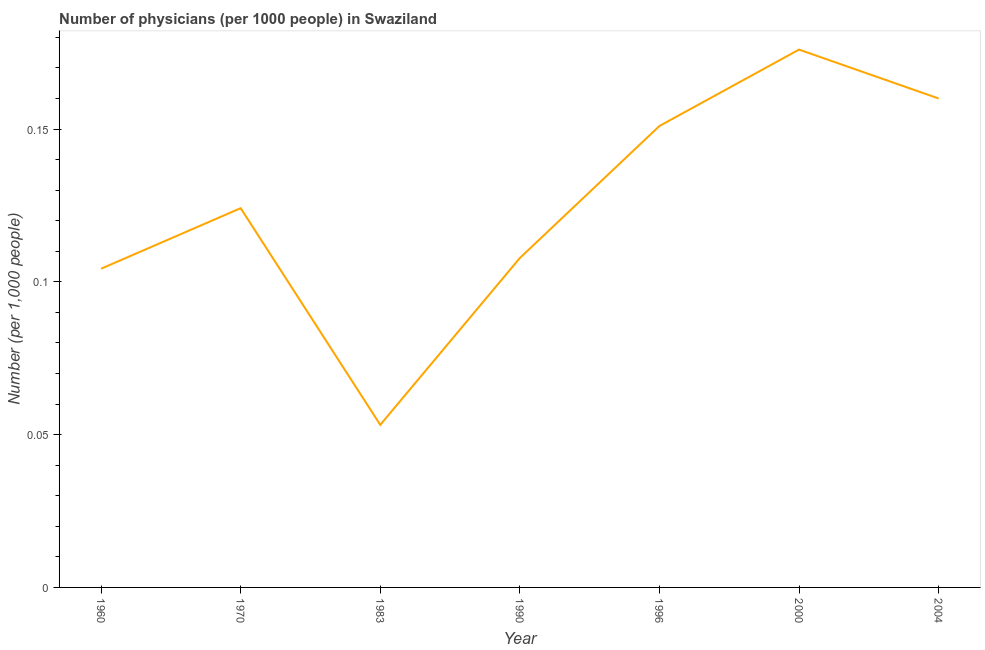What is the number of physicians in 2004?
Keep it short and to the point. 0.16. Across all years, what is the maximum number of physicians?
Offer a very short reply. 0.18. Across all years, what is the minimum number of physicians?
Offer a very short reply. 0.05. In which year was the number of physicians minimum?
Give a very brief answer. 1983. What is the sum of the number of physicians?
Provide a succinct answer. 0.88. What is the difference between the number of physicians in 1996 and 2004?
Provide a short and direct response. -0.01. What is the average number of physicians per year?
Your response must be concise. 0.13. What is the median number of physicians?
Provide a succinct answer. 0.12. What is the ratio of the number of physicians in 1983 to that in 2004?
Give a very brief answer. 0.33. Is the number of physicians in 1970 less than that in 2000?
Offer a terse response. Yes. What is the difference between the highest and the second highest number of physicians?
Provide a short and direct response. 0.02. Is the sum of the number of physicians in 1970 and 2004 greater than the maximum number of physicians across all years?
Provide a succinct answer. Yes. What is the difference between the highest and the lowest number of physicians?
Offer a terse response. 0.12. How many lines are there?
Offer a terse response. 1. How many years are there in the graph?
Offer a terse response. 7. What is the title of the graph?
Your answer should be compact. Number of physicians (per 1000 people) in Swaziland. What is the label or title of the X-axis?
Provide a short and direct response. Year. What is the label or title of the Y-axis?
Give a very brief answer. Number (per 1,0 people). What is the Number (per 1,000 people) in 1960?
Provide a short and direct response. 0.1. What is the Number (per 1,000 people) in 1970?
Offer a terse response. 0.12. What is the Number (per 1,000 people) of 1983?
Your answer should be compact. 0.05. What is the Number (per 1,000 people) in 1990?
Provide a short and direct response. 0.11. What is the Number (per 1,000 people) in 1996?
Your answer should be compact. 0.15. What is the Number (per 1,000 people) of 2000?
Make the answer very short. 0.18. What is the Number (per 1,000 people) of 2004?
Provide a short and direct response. 0.16. What is the difference between the Number (per 1,000 people) in 1960 and 1970?
Your response must be concise. -0.02. What is the difference between the Number (per 1,000 people) in 1960 and 1983?
Your response must be concise. 0.05. What is the difference between the Number (per 1,000 people) in 1960 and 1990?
Offer a terse response. -0. What is the difference between the Number (per 1,000 people) in 1960 and 1996?
Your answer should be very brief. -0.05. What is the difference between the Number (per 1,000 people) in 1960 and 2000?
Your answer should be compact. -0.07. What is the difference between the Number (per 1,000 people) in 1960 and 2004?
Your answer should be very brief. -0.06. What is the difference between the Number (per 1,000 people) in 1970 and 1983?
Keep it short and to the point. 0.07. What is the difference between the Number (per 1,000 people) in 1970 and 1990?
Your response must be concise. 0.02. What is the difference between the Number (per 1,000 people) in 1970 and 1996?
Your response must be concise. -0.03. What is the difference between the Number (per 1,000 people) in 1970 and 2000?
Ensure brevity in your answer.  -0.05. What is the difference between the Number (per 1,000 people) in 1970 and 2004?
Offer a terse response. -0.04. What is the difference between the Number (per 1,000 people) in 1983 and 1990?
Keep it short and to the point. -0.05. What is the difference between the Number (per 1,000 people) in 1983 and 1996?
Your answer should be very brief. -0.1. What is the difference between the Number (per 1,000 people) in 1983 and 2000?
Your response must be concise. -0.12. What is the difference between the Number (per 1,000 people) in 1983 and 2004?
Offer a very short reply. -0.11. What is the difference between the Number (per 1,000 people) in 1990 and 1996?
Ensure brevity in your answer.  -0.04. What is the difference between the Number (per 1,000 people) in 1990 and 2000?
Provide a succinct answer. -0.07. What is the difference between the Number (per 1,000 people) in 1990 and 2004?
Provide a succinct answer. -0.05. What is the difference between the Number (per 1,000 people) in 1996 and 2000?
Your response must be concise. -0.03. What is the difference between the Number (per 1,000 people) in 1996 and 2004?
Your response must be concise. -0.01. What is the difference between the Number (per 1,000 people) in 2000 and 2004?
Provide a succinct answer. 0.02. What is the ratio of the Number (per 1,000 people) in 1960 to that in 1970?
Provide a succinct answer. 0.84. What is the ratio of the Number (per 1,000 people) in 1960 to that in 1983?
Make the answer very short. 1.96. What is the ratio of the Number (per 1,000 people) in 1960 to that in 1996?
Your response must be concise. 0.69. What is the ratio of the Number (per 1,000 people) in 1960 to that in 2000?
Make the answer very short. 0.59. What is the ratio of the Number (per 1,000 people) in 1960 to that in 2004?
Ensure brevity in your answer.  0.65. What is the ratio of the Number (per 1,000 people) in 1970 to that in 1983?
Your answer should be very brief. 2.33. What is the ratio of the Number (per 1,000 people) in 1970 to that in 1990?
Provide a succinct answer. 1.15. What is the ratio of the Number (per 1,000 people) in 1970 to that in 1996?
Make the answer very short. 0.82. What is the ratio of the Number (per 1,000 people) in 1970 to that in 2000?
Offer a very short reply. 0.7. What is the ratio of the Number (per 1,000 people) in 1970 to that in 2004?
Provide a short and direct response. 0.78. What is the ratio of the Number (per 1,000 people) in 1983 to that in 1990?
Make the answer very short. 0.49. What is the ratio of the Number (per 1,000 people) in 1983 to that in 1996?
Provide a succinct answer. 0.35. What is the ratio of the Number (per 1,000 people) in 1983 to that in 2000?
Keep it short and to the point. 0.3. What is the ratio of the Number (per 1,000 people) in 1983 to that in 2004?
Offer a very short reply. 0.33. What is the ratio of the Number (per 1,000 people) in 1990 to that in 1996?
Offer a very short reply. 0.71. What is the ratio of the Number (per 1,000 people) in 1990 to that in 2000?
Your response must be concise. 0.61. What is the ratio of the Number (per 1,000 people) in 1990 to that in 2004?
Your answer should be very brief. 0.67. What is the ratio of the Number (per 1,000 people) in 1996 to that in 2000?
Provide a short and direct response. 0.86. What is the ratio of the Number (per 1,000 people) in 1996 to that in 2004?
Keep it short and to the point. 0.94. What is the ratio of the Number (per 1,000 people) in 2000 to that in 2004?
Offer a very short reply. 1.1. 